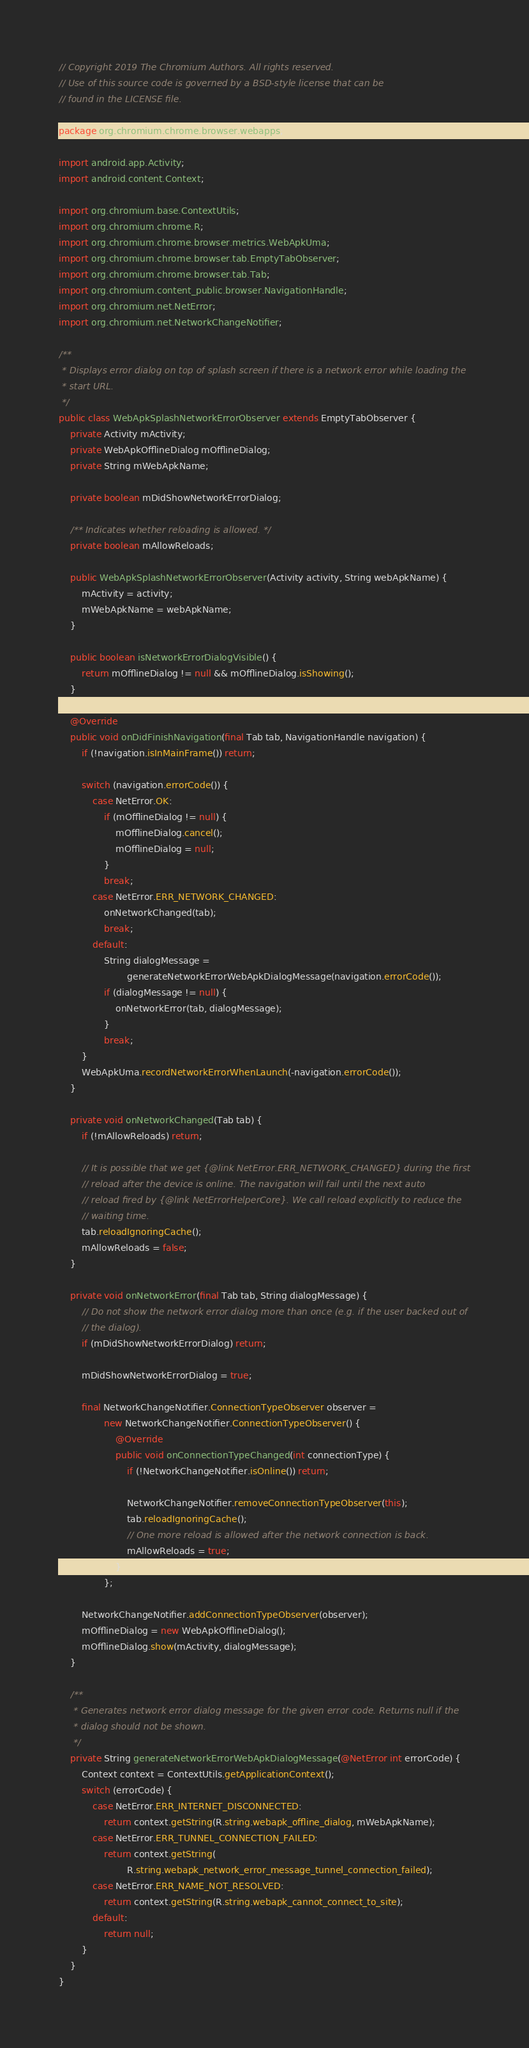Convert code to text. <code><loc_0><loc_0><loc_500><loc_500><_Java_>// Copyright 2019 The Chromium Authors. All rights reserved.
// Use of this source code is governed by a BSD-style license that can be
// found in the LICENSE file.

package org.chromium.chrome.browser.webapps;

import android.app.Activity;
import android.content.Context;

import org.chromium.base.ContextUtils;
import org.chromium.chrome.R;
import org.chromium.chrome.browser.metrics.WebApkUma;
import org.chromium.chrome.browser.tab.EmptyTabObserver;
import org.chromium.chrome.browser.tab.Tab;
import org.chromium.content_public.browser.NavigationHandle;
import org.chromium.net.NetError;
import org.chromium.net.NetworkChangeNotifier;

/**
 * Displays error dialog on top of splash screen if there is a network error while loading the
 * start URL.
 */
public class WebApkSplashNetworkErrorObserver extends EmptyTabObserver {
    private Activity mActivity;
    private WebApkOfflineDialog mOfflineDialog;
    private String mWebApkName;

    private boolean mDidShowNetworkErrorDialog;

    /** Indicates whether reloading is allowed. */
    private boolean mAllowReloads;

    public WebApkSplashNetworkErrorObserver(Activity activity, String webApkName) {
        mActivity = activity;
        mWebApkName = webApkName;
    }

    public boolean isNetworkErrorDialogVisible() {
        return mOfflineDialog != null && mOfflineDialog.isShowing();
    }

    @Override
    public void onDidFinishNavigation(final Tab tab, NavigationHandle navigation) {
        if (!navigation.isInMainFrame()) return;

        switch (navigation.errorCode()) {
            case NetError.OK:
                if (mOfflineDialog != null) {
                    mOfflineDialog.cancel();
                    mOfflineDialog = null;
                }
                break;
            case NetError.ERR_NETWORK_CHANGED:
                onNetworkChanged(tab);
                break;
            default:
                String dialogMessage =
                        generateNetworkErrorWebApkDialogMessage(navigation.errorCode());
                if (dialogMessage != null) {
                    onNetworkError(tab, dialogMessage);
                }
                break;
        }
        WebApkUma.recordNetworkErrorWhenLaunch(-navigation.errorCode());
    }

    private void onNetworkChanged(Tab tab) {
        if (!mAllowReloads) return;

        // It is possible that we get {@link NetError.ERR_NETWORK_CHANGED} during the first
        // reload after the device is online. The navigation will fail until the next auto
        // reload fired by {@link NetErrorHelperCore}. We call reload explicitly to reduce the
        // waiting time.
        tab.reloadIgnoringCache();
        mAllowReloads = false;
    }

    private void onNetworkError(final Tab tab, String dialogMessage) {
        // Do not show the network error dialog more than once (e.g. if the user backed out of
        // the dialog).
        if (mDidShowNetworkErrorDialog) return;

        mDidShowNetworkErrorDialog = true;

        final NetworkChangeNotifier.ConnectionTypeObserver observer =
                new NetworkChangeNotifier.ConnectionTypeObserver() {
                    @Override
                    public void onConnectionTypeChanged(int connectionType) {
                        if (!NetworkChangeNotifier.isOnline()) return;

                        NetworkChangeNotifier.removeConnectionTypeObserver(this);
                        tab.reloadIgnoringCache();
                        // One more reload is allowed after the network connection is back.
                        mAllowReloads = true;
                    }
                };

        NetworkChangeNotifier.addConnectionTypeObserver(observer);
        mOfflineDialog = new WebApkOfflineDialog();
        mOfflineDialog.show(mActivity, dialogMessage);
    }

    /**
     * Generates network error dialog message for the given error code. Returns null if the
     * dialog should not be shown.
     */
    private String generateNetworkErrorWebApkDialogMessage(@NetError int errorCode) {
        Context context = ContextUtils.getApplicationContext();
        switch (errorCode) {
            case NetError.ERR_INTERNET_DISCONNECTED:
                return context.getString(R.string.webapk_offline_dialog, mWebApkName);
            case NetError.ERR_TUNNEL_CONNECTION_FAILED:
                return context.getString(
                        R.string.webapk_network_error_message_tunnel_connection_failed);
            case NetError.ERR_NAME_NOT_RESOLVED:
                return context.getString(R.string.webapk_cannot_connect_to_site);
            default:
                return null;
        }
    }
}
</code> 